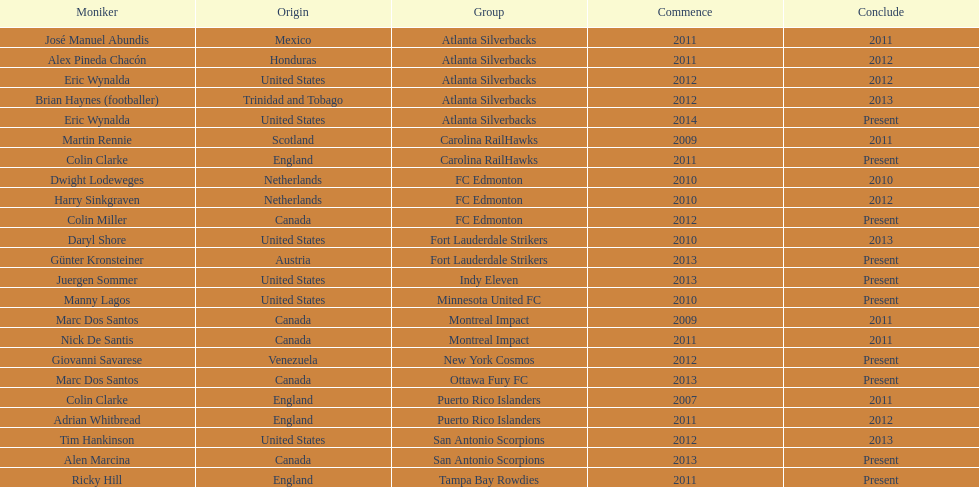Who was the coach of fc edmonton before miller? Harry Sinkgraven. 